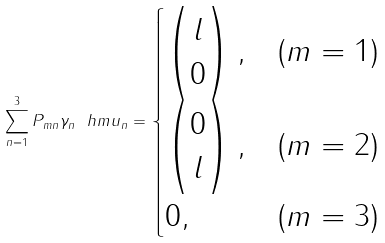Convert formula to latex. <formula><loc_0><loc_0><loc_500><loc_500>\sum _ { n = 1 } ^ { 3 } P _ { m n } \gamma _ { n } \ h m u _ { n } = \begin{cases} \left ( \begin{matrix} l \\ 0 \end{matrix} \right ) , & ( m = 1 ) \\ \left ( \begin{matrix} 0 \\ l \end{matrix} \right ) , & ( m = 2 ) \\ 0 , & ( m = 3 ) \end{cases}</formula> 